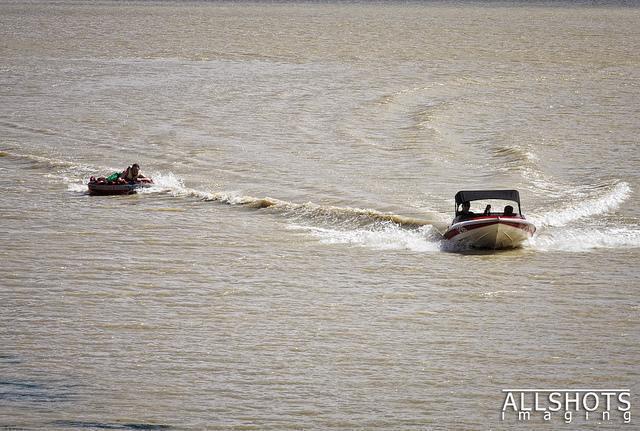How many boats are shown?
Give a very brief answer. 1. 